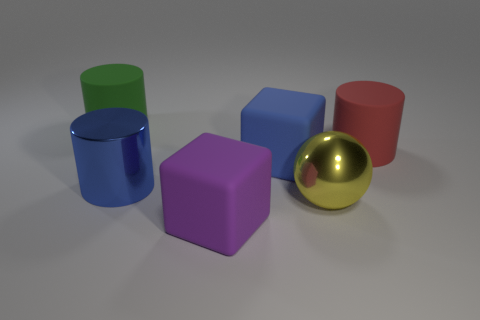Subtract all large metallic cylinders. How many cylinders are left? 2 Add 3 big yellow shiny things. How many objects exist? 9 Subtract all cubes. How many objects are left? 4 Subtract all green cylinders. Subtract all green spheres. How many cylinders are left? 2 Subtract all large blue cubes. Subtract all large red cubes. How many objects are left? 5 Add 4 large yellow spheres. How many large yellow spheres are left? 5 Add 6 big red objects. How many big red objects exist? 7 Subtract 0 green blocks. How many objects are left? 6 